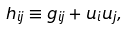<formula> <loc_0><loc_0><loc_500><loc_500>h _ { i j } \equiv g _ { i j } + u _ { i } u _ { j } ,</formula> 